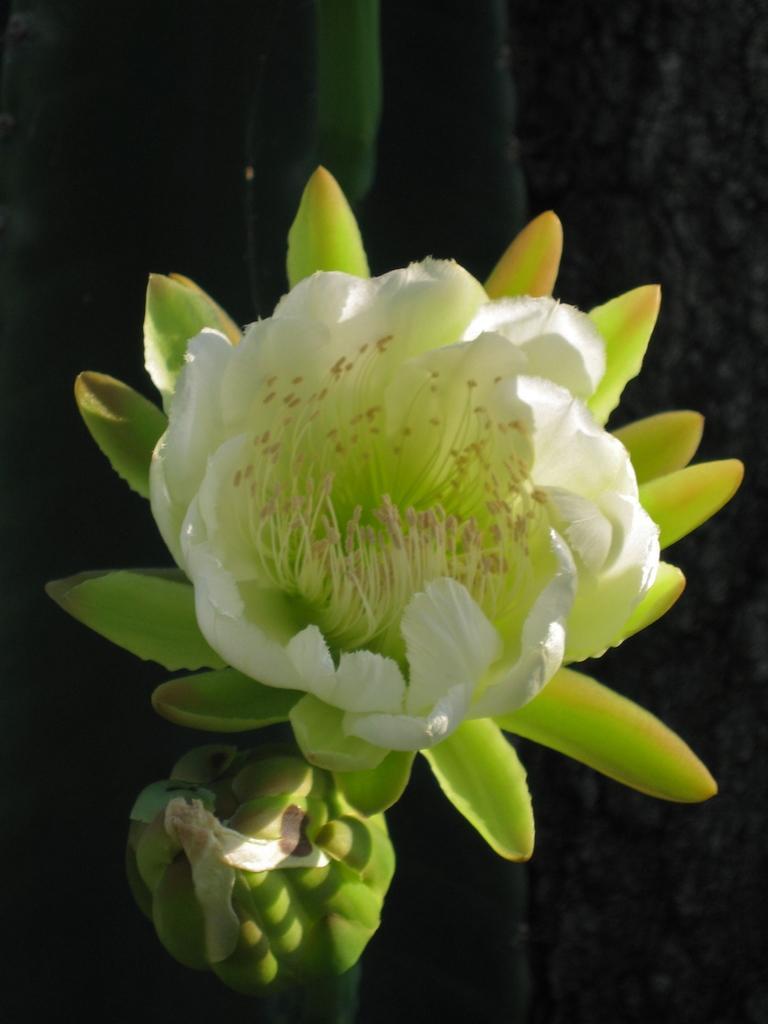Please provide a concise description of this image. In this image I can see a flower which is in white and green color. 